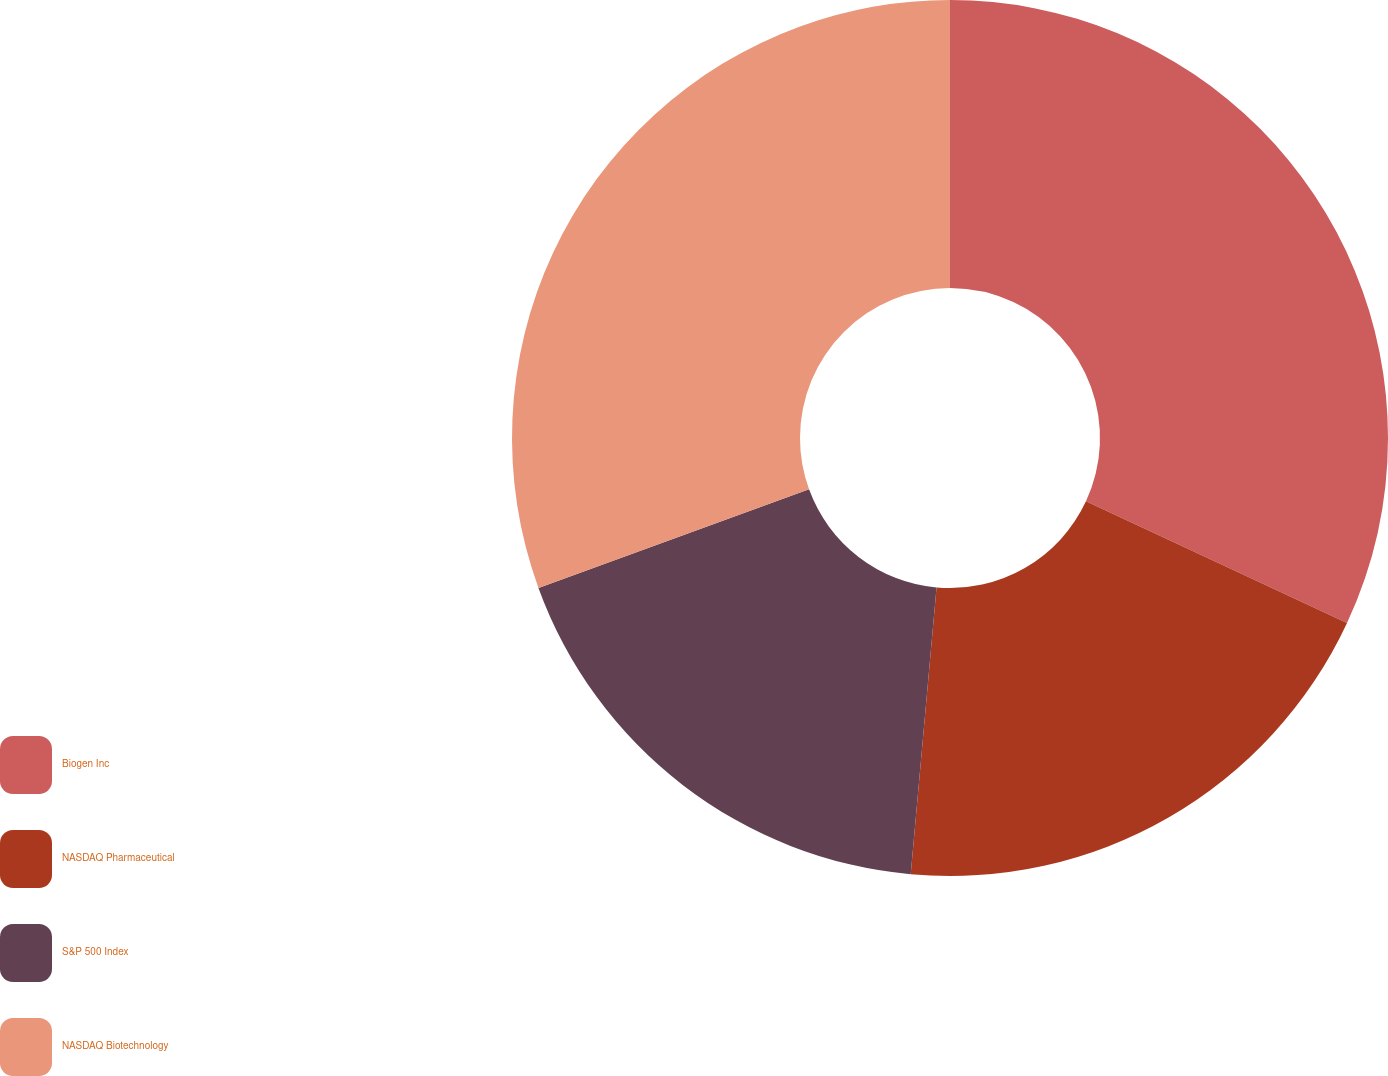Convert chart to OTSL. <chart><loc_0><loc_0><loc_500><loc_500><pie_chart><fcel>Biogen Inc<fcel>NASDAQ Pharmaceutical<fcel>S&P 500 Index<fcel>NASDAQ Biotechnology<nl><fcel>31.94%<fcel>19.49%<fcel>18.01%<fcel>30.56%<nl></chart> 